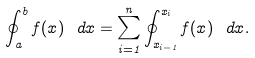Convert formula to latex. <formula><loc_0><loc_0><loc_500><loc_500>\oint _ { a } ^ { b } f ( x ) \ d x = \sum _ { i = 1 } ^ { n } \oint _ { x _ { i - 1 } } ^ { x _ { i } } f ( x ) \ d x .</formula> 